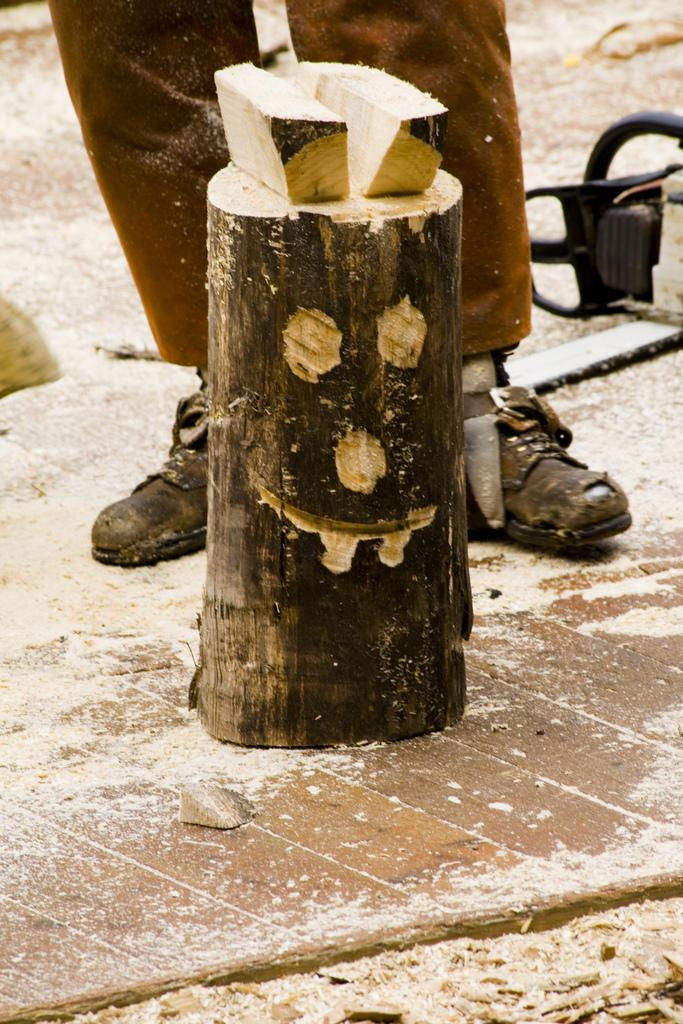What is the main object in the image? There is a wooden pole in the image. Can you describe the person in the background? The person is wearing brown pants and black shoes. What color is the object on the right side of the image? The object is in black color. What type of chain can be seen connecting the person to the wooden pole in the image? There is no chain connecting the person to the wooden pole in the image. What line of work does the person appear to be in based on their attire in the image? The provided facts do not give enough information to determine the person's line of work based on their attire. 